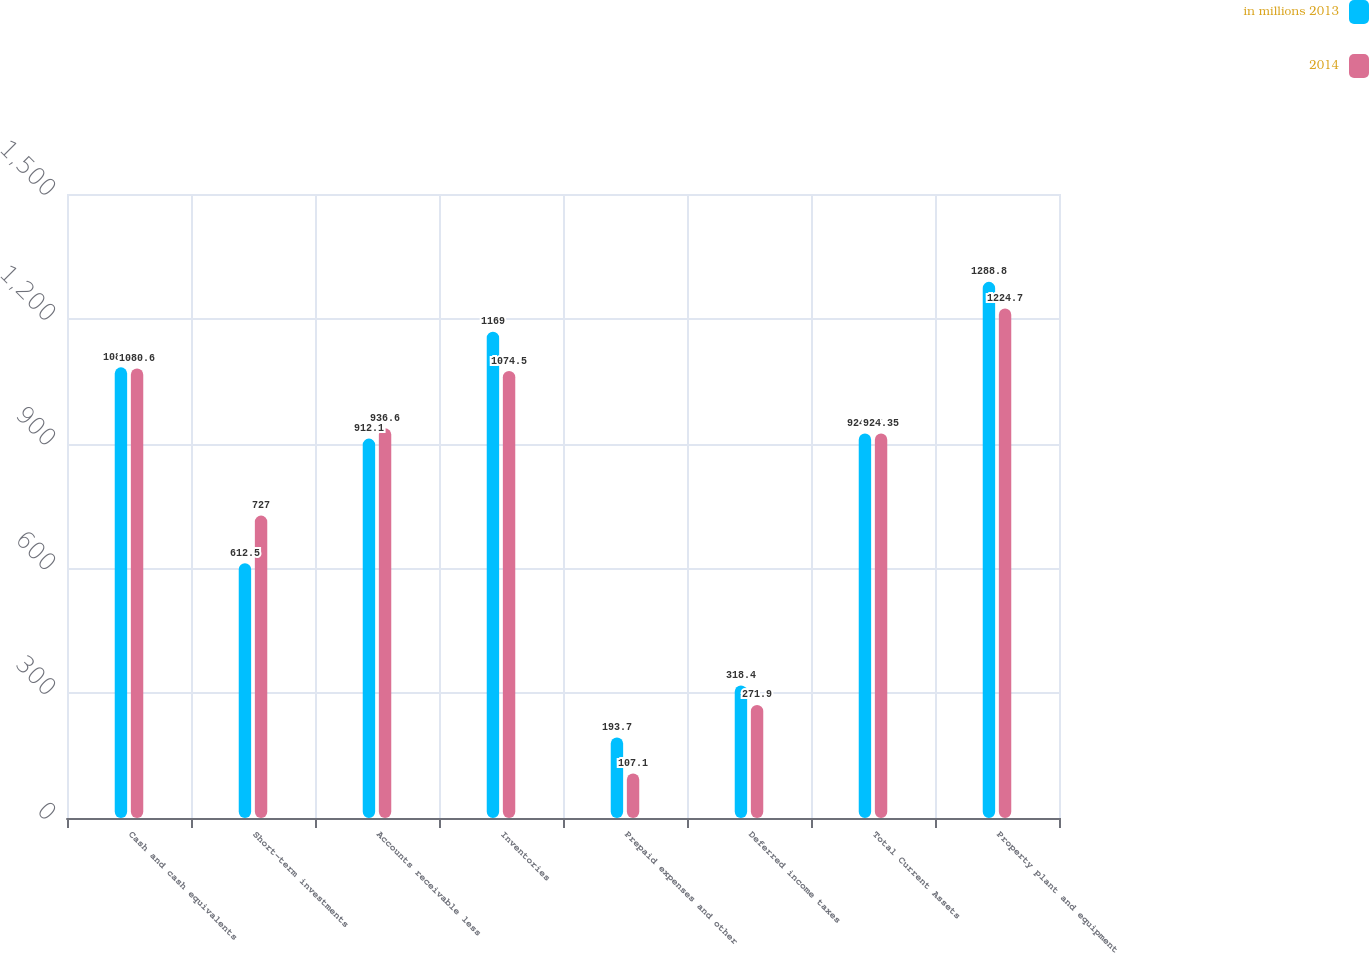<chart> <loc_0><loc_0><loc_500><loc_500><stacked_bar_chart><ecel><fcel>Cash and cash equivalents<fcel>Short-term investments<fcel>Accounts receivable less<fcel>Inventories<fcel>Prepaid expenses and other<fcel>Deferred income taxes<fcel>Total Current Assets<fcel>Property plant and equipment<nl><fcel>in millions 2013<fcel>1083.3<fcel>612.5<fcel>912.1<fcel>1169<fcel>193.7<fcel>318.4<fcel>924.35<fcel>1288.8<nl><fcel>2014<fcel>1080.6<fcel>727<fcel>936.6<fcel>1074.5<fcel>107.1<fcel>271.9<fcel>924.35<fcel>1224.7<nl></chart> 